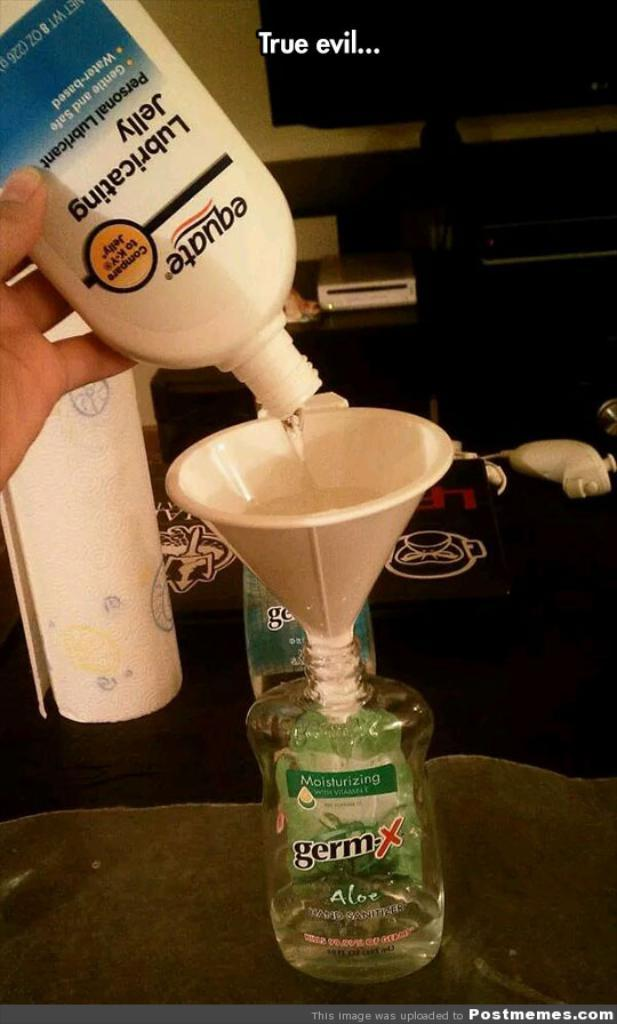<image>
Share a concise interpretation of the image provided. A bottle of lubricating jelly being put into a germ-x bottle with the use of a funnel. 